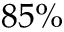Convert formula to latex. <formula><loc_0><loc_0><loc_500><loc_500>8 5 \%</formula> 